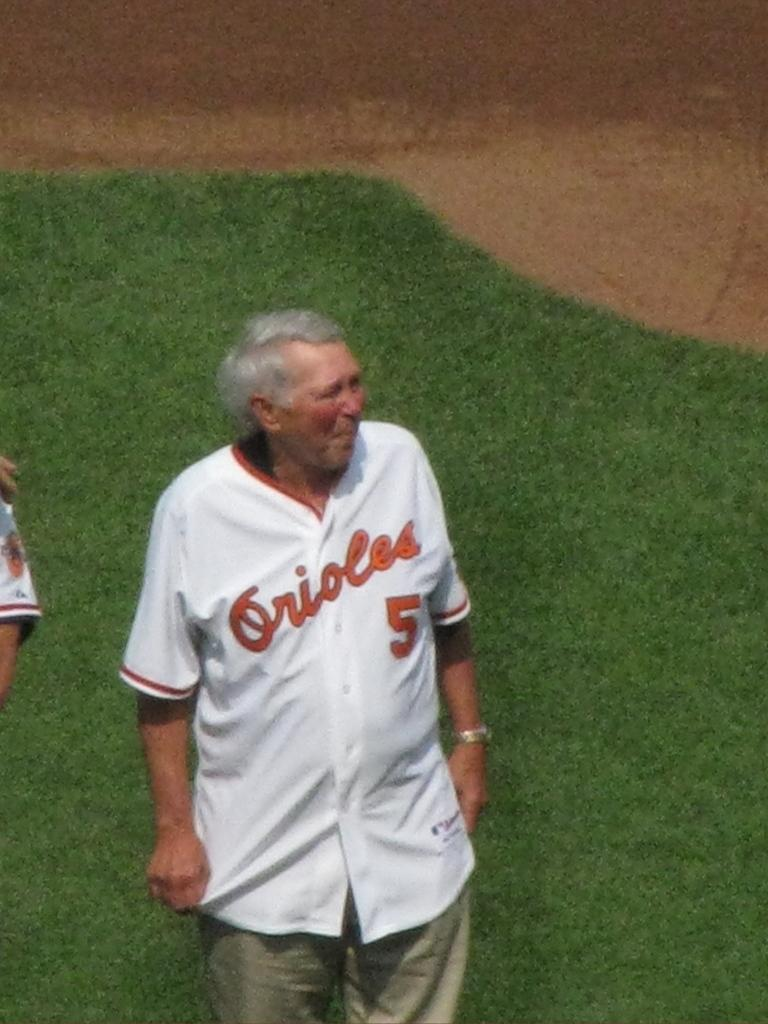<image>
Present a compact description of the photo's key features. An old man wearing a number 5 Orioles jersey stands on a baseball field. 